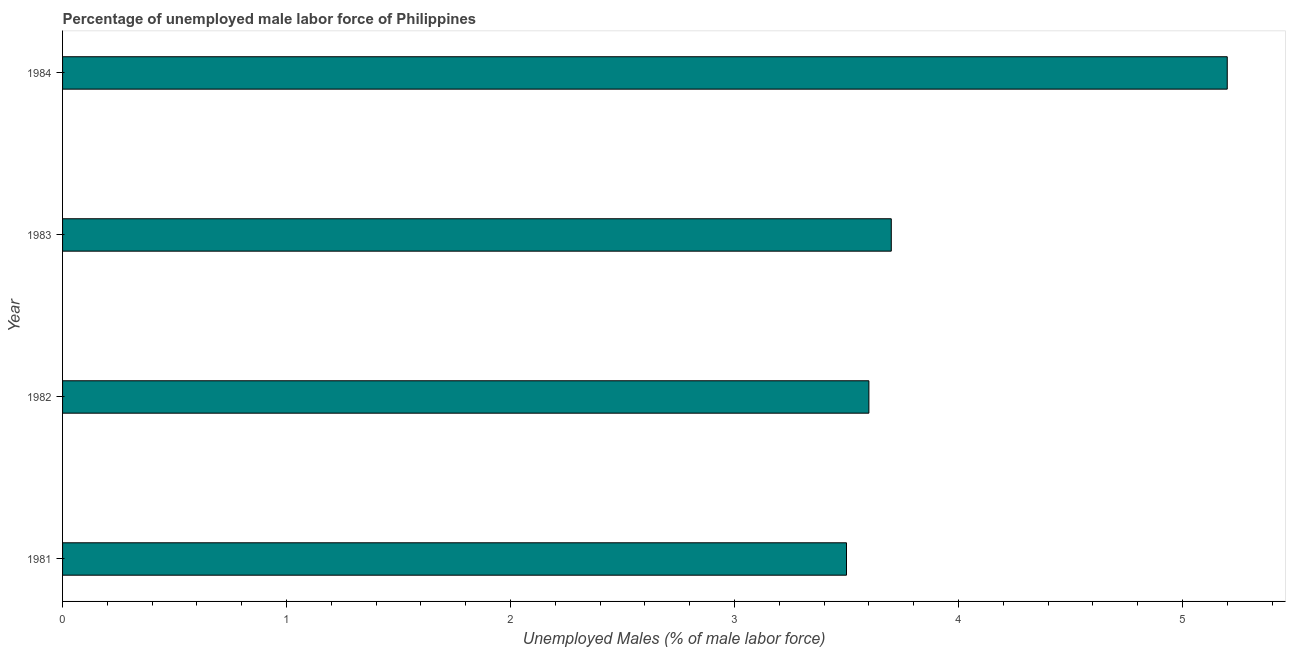Does the graph contain any zero values?
Provide a short and direct response. No. What is the title of the graph?
Offer a very short reply. Percentage of unemployed male labor force of Philippines. What is the label or title of the X-axis?
Offer a very short reply. Unemployed Males (% of male labor force). What is the label or title of the Y-axis?
Give a very brief answer. Year. What is the total unemployed male labour force in 1983?
Ensure brevity in your answer.  3.7. Across all years, what is the maximum total unemployed male labour force?
Offer a terse response. 5.2. In which year was the total unemployed male labour force minimum?
Your response must be concise. 1981. What is the sum of the total unemployed male labour force?
Give a very brief answer. 16. What is the difference between the total unemployed male labour force in 1983 and 1984?
Ensure brevity in your answer.  -1.5. What is the average total unemployed male labour force per year?
Provide a short and direct response. 4. What is the median total unemployed male labour force?
Your response must be concise. 3.65. In how many years, is the total unemployed male labour force greater than 2 %?
Make the answer very short. 4. What is the ratio of the total unemployed male labour force in 1981 to that in 1984?
Your answer should be very brief. 0.67. Is the difference between the total unemployed male labour force in 1981 and 1983 greater than the difference between any two years?
Your answer should be very brief. No. Is the sum of the total unemployed male labour force in 1983 and 1984 greater than the maximum total unemployed male labour force across all years?
Your answer should be compact. Yes. In how many years, is the total unemployed male labour force greater than the average total unemployed male labour force taken over all years?
Give a very brief answer. 1. How many bars are there?
Provide a short and direct response. 4. Are all the bars in the graph horizontal?
Give a very brief answer. Yes. Are the values on the major ticks of X-axis written in scientific E-notation?
Give a very brief answer. No. What is the Unemployed Males (% of male labor force) of 1982?
Keep it short and to the point. 3.6. What is the Unemployed Males (% of male labor force) of 1983?
Offer a very short reply. 3.7. What is the Unemployed Males (% of male labor force) in 1984?
Your answer should be compact. 5.2. What is the difference between the Unemployed Males (% of male labor force) in 1981 and 1983?
Your answer should be very brief. -0.2. What is the difference between the Unemployed Males (% of male labor force) in 1981 and 1984?
Provide a short and direct response. -1.7. What is the ratio of the Unemployed Males (% of male labor force) in 1981 to that in 1982?
Make the answer very short. 0.97. What is the ratio of the Unemployed Males (% of male labor force) in 1981 to that in 1983?
Keep it short and to the point. 0.95. What is the ratio of the Unemployed Males (% of male labor force) in 1981 to that in 1984?
Make the answer very short. 0.67. What is the ratio of the Unemployed Males (% of male labor force) in 1982 to that in 1983?
Make the answer very short. 0.97. What is the ratio of the Unemployed Males (% of male labor force) in 1982 to that in 1984?
Your answer should be compact. 0.69. What is the ratio of the Unemployed Males (% of male labor force) in 1983 to that in 1984?
Offer a terse response. 0.71. 